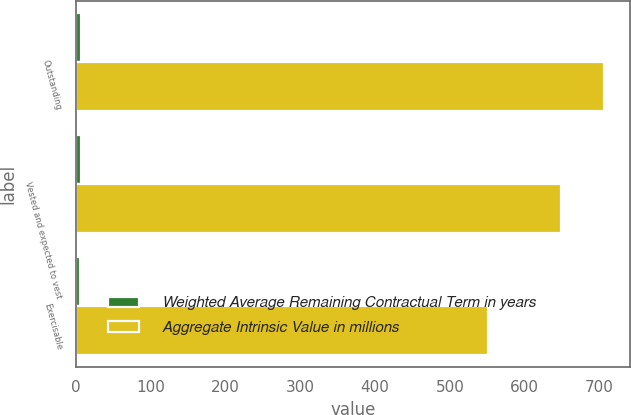Convert chart. <chart><loc_0><loc_0><loc_500><loc_500><stacked_bar_chart><ecel><fcel>Outstanding<fcel>Vested and expected to vest<fcel>Exercisable<nl><fcel>Weighted Average Remaining Contractual Term in years<fcel>6.58<fcel>6.39<fcel>5.59<nl><fcel>Aggregate Intrinsic Value in millions<fcel>706<fcel>649<fcel>551<nl></chart> 